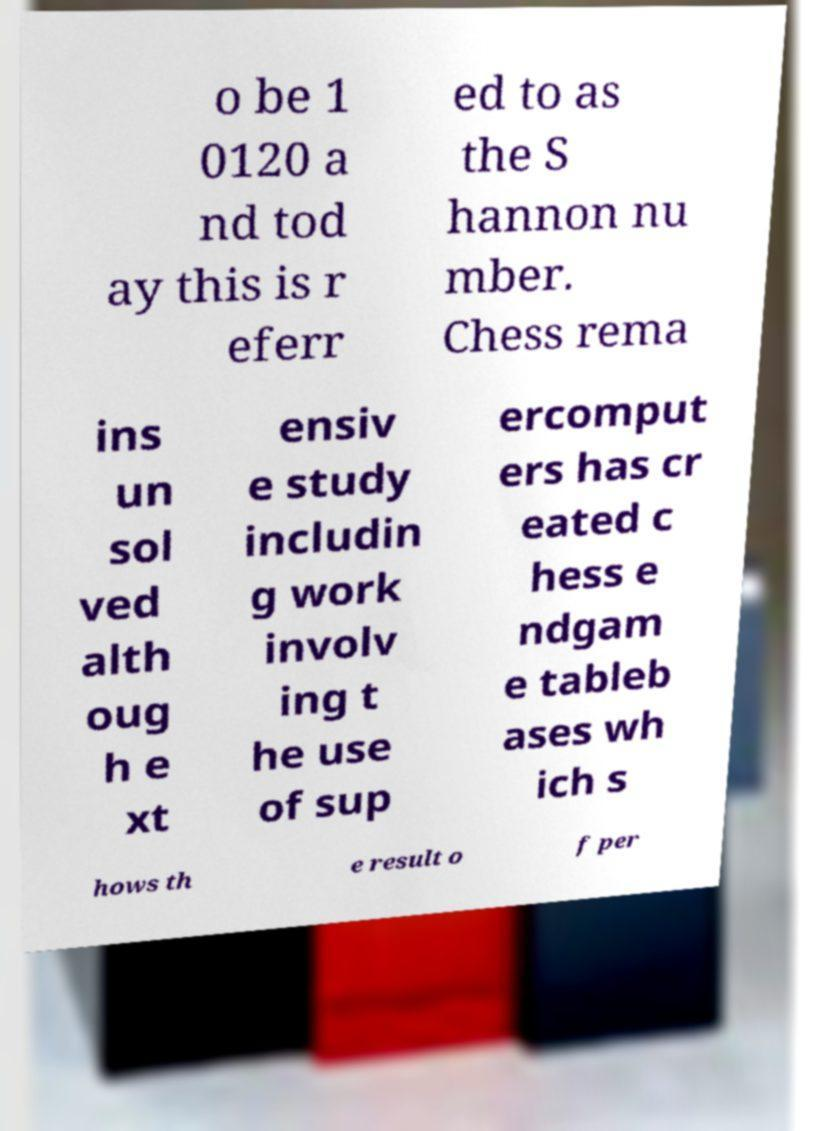I need the written content from this picture converted into text. Can you do that? o be 1 0120 a nd tod ay this is r eferr ed to as the S hannon nu mber. Chess rema ins un sol ved alth oug h e xt ensiv e study includin g work involv ing t he use of sup ercomput ers has cr eated c hess e ndgam e tableb ases wh ich s hows th e result o f per 